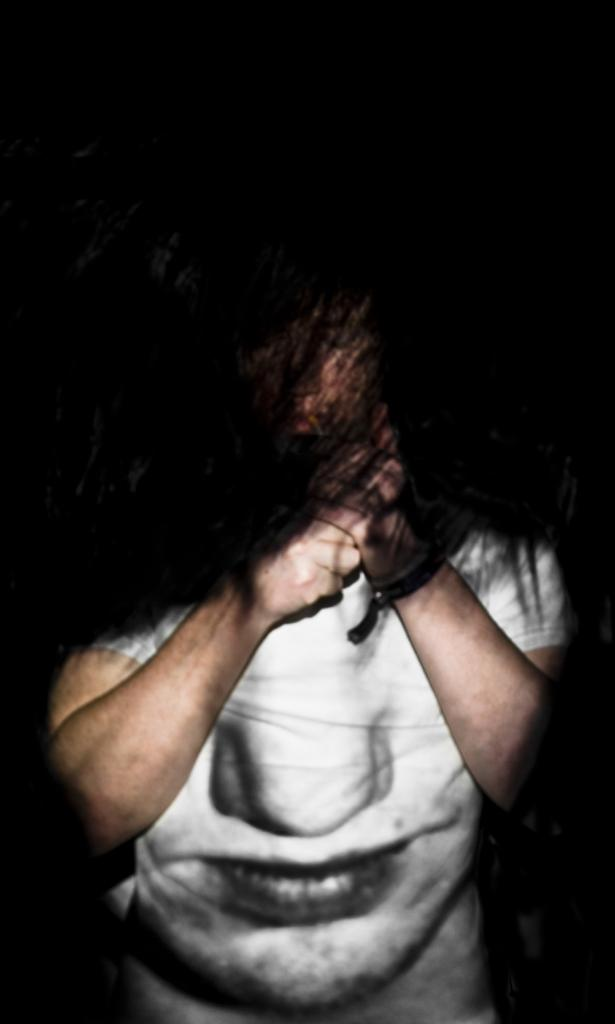What is the main subject of the image? There is a person in the image. What is the person wearing? The person is wearing a white t-shirt. What is depicted on the t-shirt? The t-shirt has a depiction of a human nose and mouth. How would you describe the background of the image? The background of the image has a dark view. What type of pan can be seen in the person's hand in the image? There is no pan present in the image; the person is wearing a t-shirt with a depiction of a human nose and mouth. 